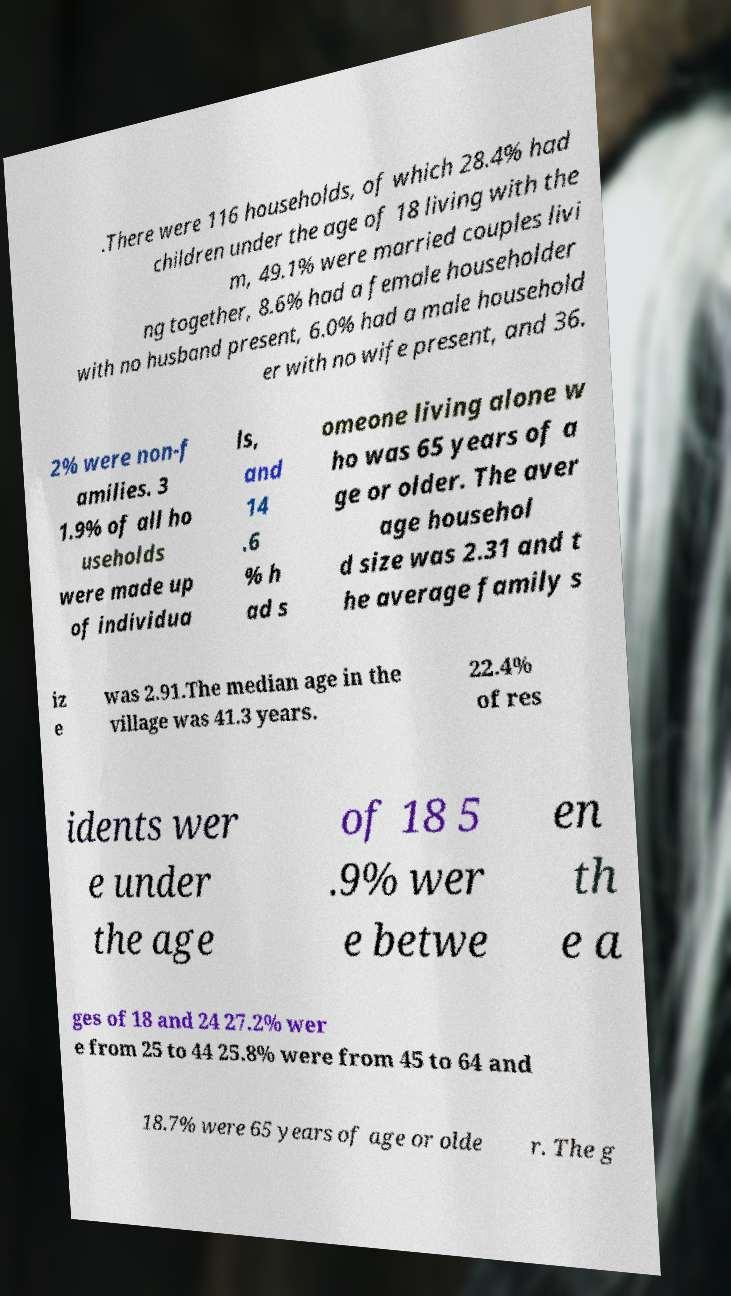Could you extract and type out the text from this image? .There were 116 households, of which 28.4% had children under the age of 18 living with the m, 49.1% were married couples livi ng together, 8.6% had a female householder with no husband present, 6.0% had a male household er with no wife present, and 36. 2% were non-f amilies. 3 1.9% of all ho useholds were made up of individua ls, and 14 .6 % h ad s omeone living alone w ho was 65 years of a ge or older. The aver age househol d size was 2.31 and t he average family s iz e was 2.91.The median age in the village was 41.3 years. 22.4% of res idents wer e under the age of 18 5 .9% wer e betwe en th e a ges of 18 and 24 27.2% wer e from 25 to 44 25.8% were from 45 to 64 and 18.7% were 65 years of age or olde r. The g 